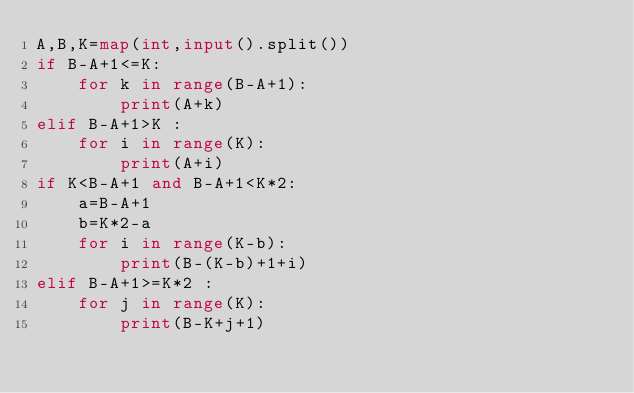<code> <loc_0><loc_0><loc_500><loc_500><_Python_>A,B,K=map(int,input().split())
if B-A+1<=K:
    for k in range(B-A+1):
        print(A+k)
elif B-A+1>K :
    for i in range(K):
        print(A+i)
if K<B-A+1 and B-A+1<K*2:
    a=B-A+1
    b=K*2-a
    for i in range(K-b):
        print(B-(K-b)+1+i)
elif B-A+1>=K*2 :
    for j in range(K):
        print(B-K+j+1)
</code> 